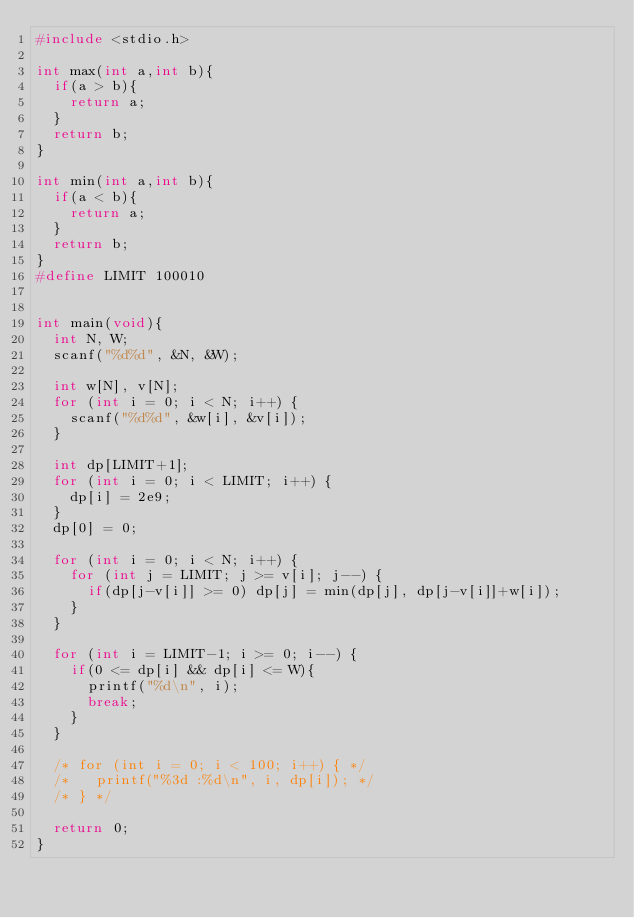Convert code to text. <code><loc_0><loc_0><loc_500><loc_500><_C_>#include <stdio.h>

int max(int a,int b){
  if(a > b){
    return a;
  }
  return b;
}

int min(int a,int b){
  if(a < b){
    return a;
  }
  return b;
}
#define LIMIT 100010


int main(void){
  int N, W;
  scanf("%d%d", &N, &W);

  int w[N], v[N];
  for (int i = 0; i < N; i++) {
    scanf("%d%d", &w[i], &v[i]);
  }

  int dp[LIMIT+1];
  for (int i = 0; i < LIMIT; i++) {
    dp[i] = 2e9;
  }
  dp[0] = 0;

  for (int i = 0; i < N; i++) {
    for (int j = LIMIT; j >= v[i]; j--) {
      if(dp[j-v[i]] >= 0) dp[j] = min(dp[j], dp[j-v[i]]+w[i]);
    }
  }

  for (int i = LIMIT-1; i >= 0; i--) {
    if(0 <= dp[i] && dp[i] <= W){
      printf("%d\n", i);
      break;
    }
  }

  /* for (int i = 0; i < 100; i++) { */
  /*   printf("%3d :%d\n", i, dp[i]); */
  /* } */ 

  return 0;
}</code> 